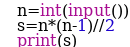Convert code to text. <code><loc_0><loc_0><loc_500><loc_500><_Python_>n=int(input())
s=n*(n-1)//2
print(s)
</code> 